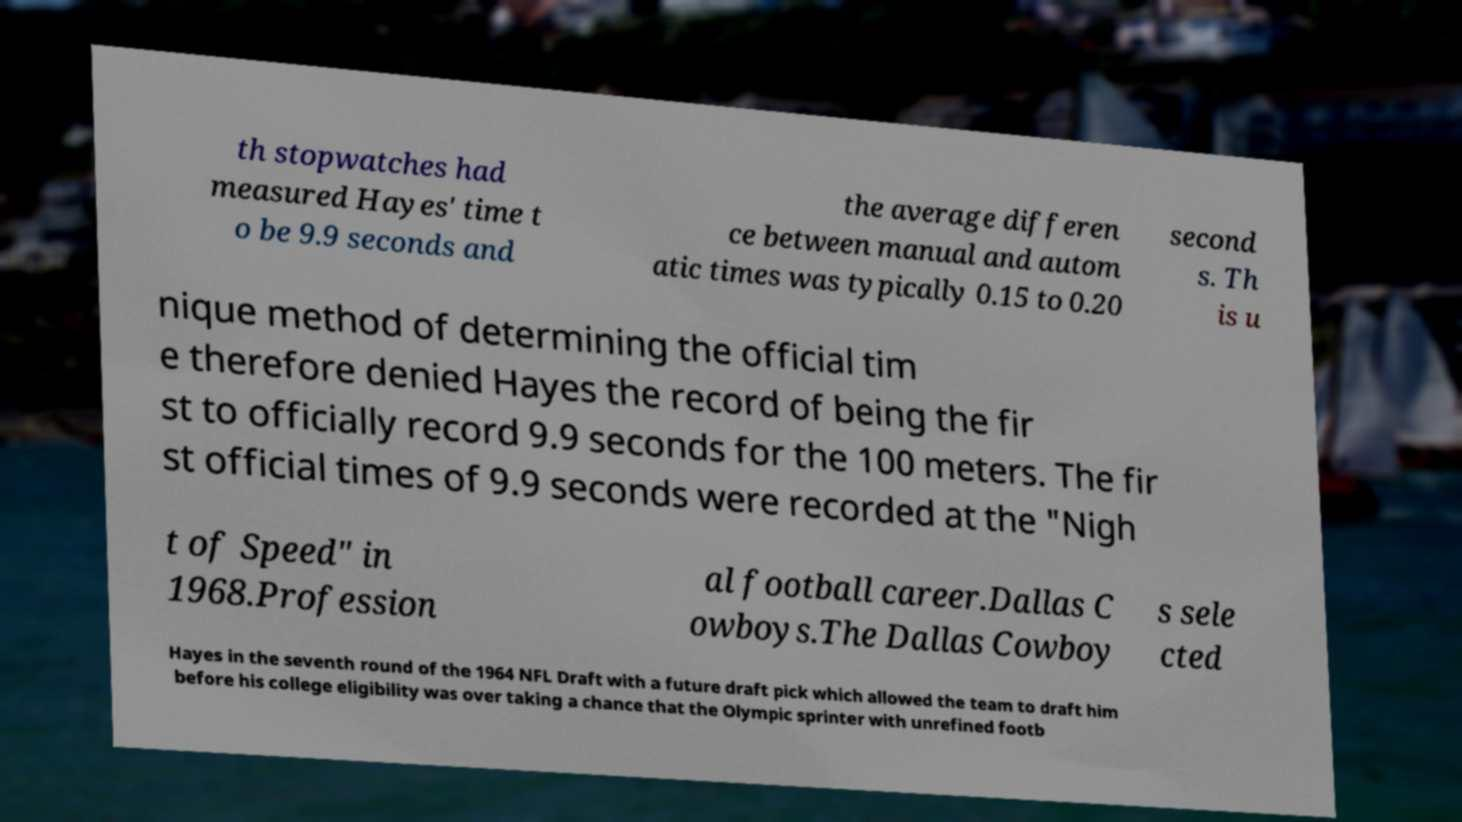Could you extract and type out the text from this image? th stopwatches had measured Hayes' time t o be 9.9 seconds and the average differen ce between manual and autom atic times was typically 0.15 to 0.20 second s. Th is u nique method of determining the official tim e therefore denied Hayes the record of being the fir st to officially record 9.9 seconds for the 100 meters. The fir st official times of 9.9 seconds were recorded at the "Nigh t of Speed" in 1968.Profession al football career.Dallas C owboys.The Dallas Cowboy s sele cted Hayes in the seventh round of the 1964 NFL Draft with a future draft pick which allowed the team to draft him before his college eligibility was over taking a chance that the Olympic sprinter with unrefined footb 